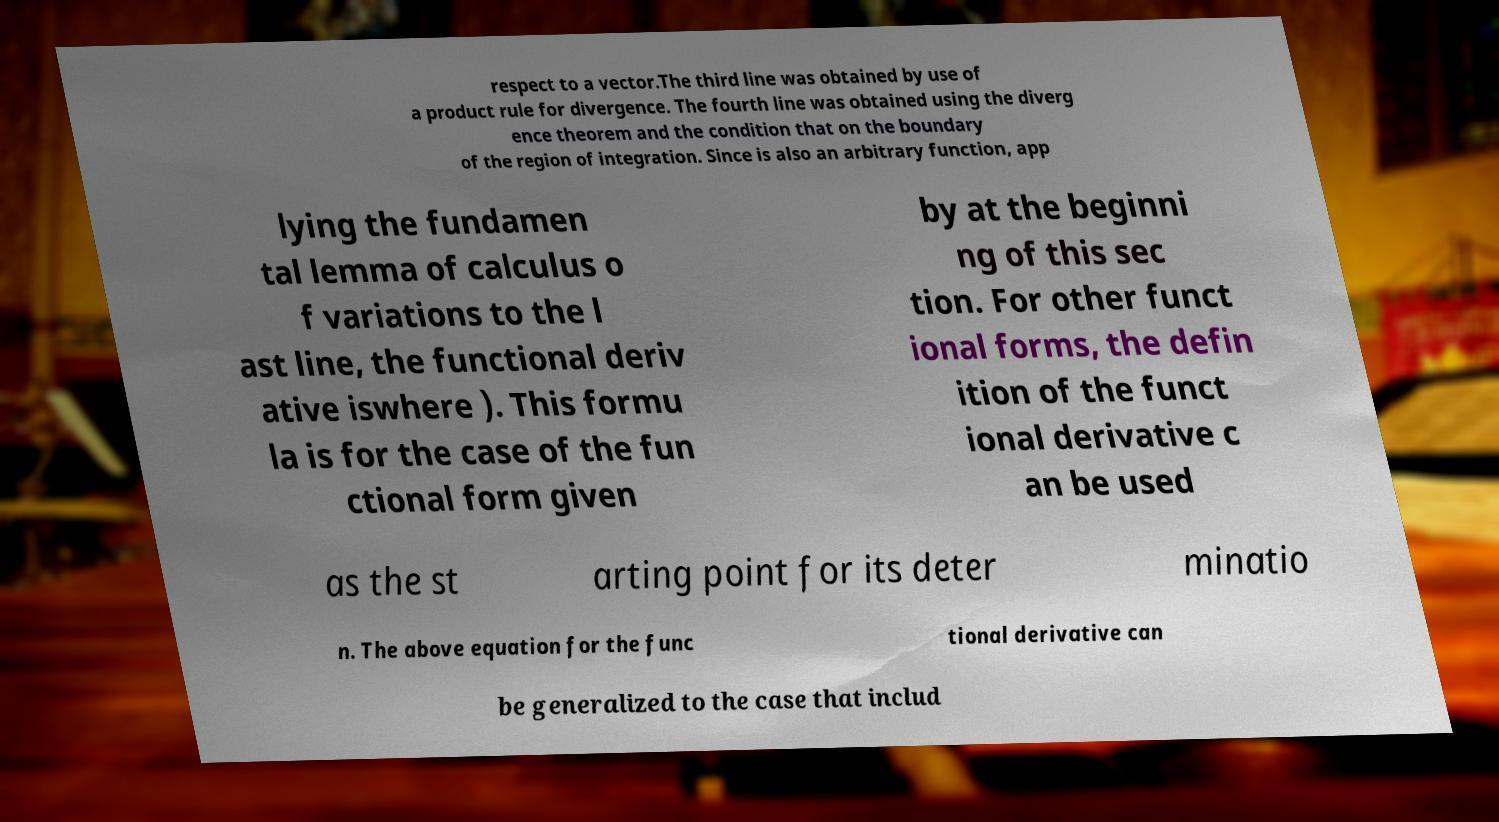For documentation purposes, I need the text within this image transcribed. Could you provide that? respect to a vector.The third line was obtained by use of a product rule for divergence. The fourth line was obtained using the diverg ence theorem and the condition that on the boundary of the region of integration. Since is also an arbitrary function, app lying the fundamen tal lemma of calculus o f variations to the l ast line, the functional deriv ative iswhere ). This formu la is for the case of the fun ctional form given by at the beginni ng of this sec tion. For other funct ional forms, the defin ition of the funct ional derivative c an be used as the st arting point for its deter minatio n. The above equation for the func tional derivative can be generalized to the case that includ 